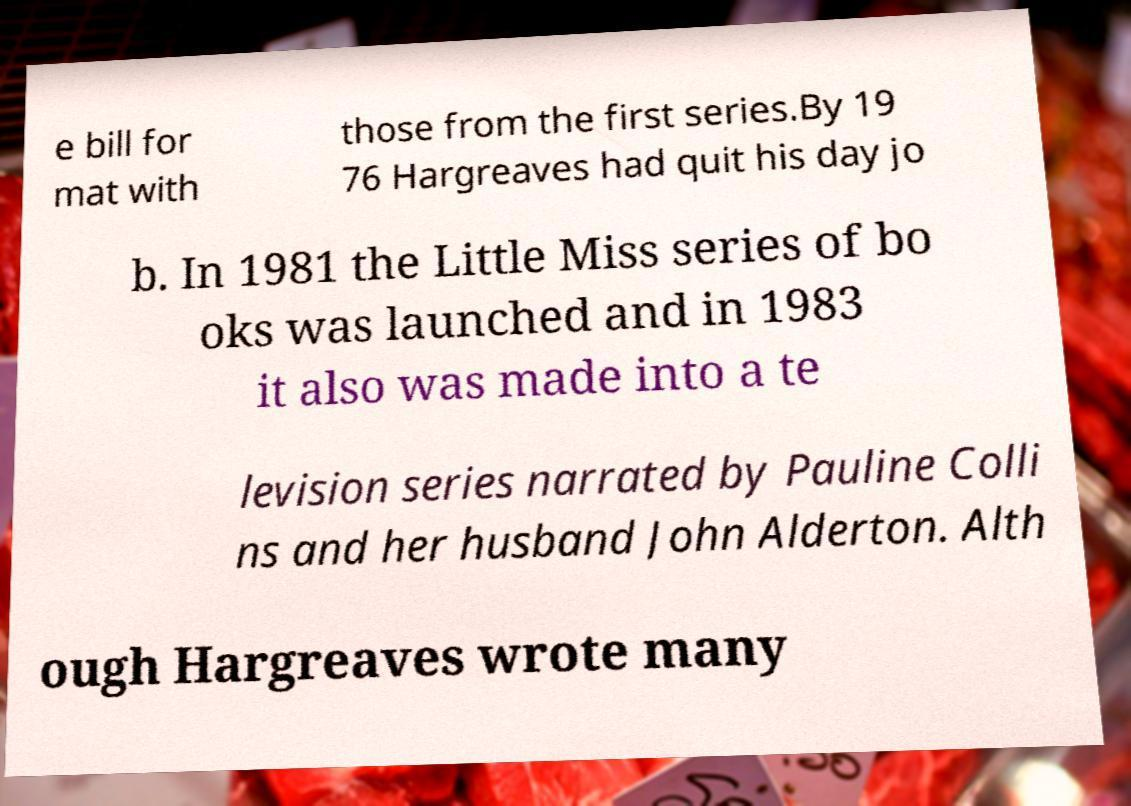What messages or text are displayed in this image? I need them in a readable, typed format. e bill for mat with those from the first series.By 19 76 Hargreaves had quit his day jo b. In 1981 the Little Miss series of bo oks was launched and in 1983 it also was made into a te levision series narrated by Pauline Colli ns and her husband John Alderton. Alth ough Hargreaves wrote many 